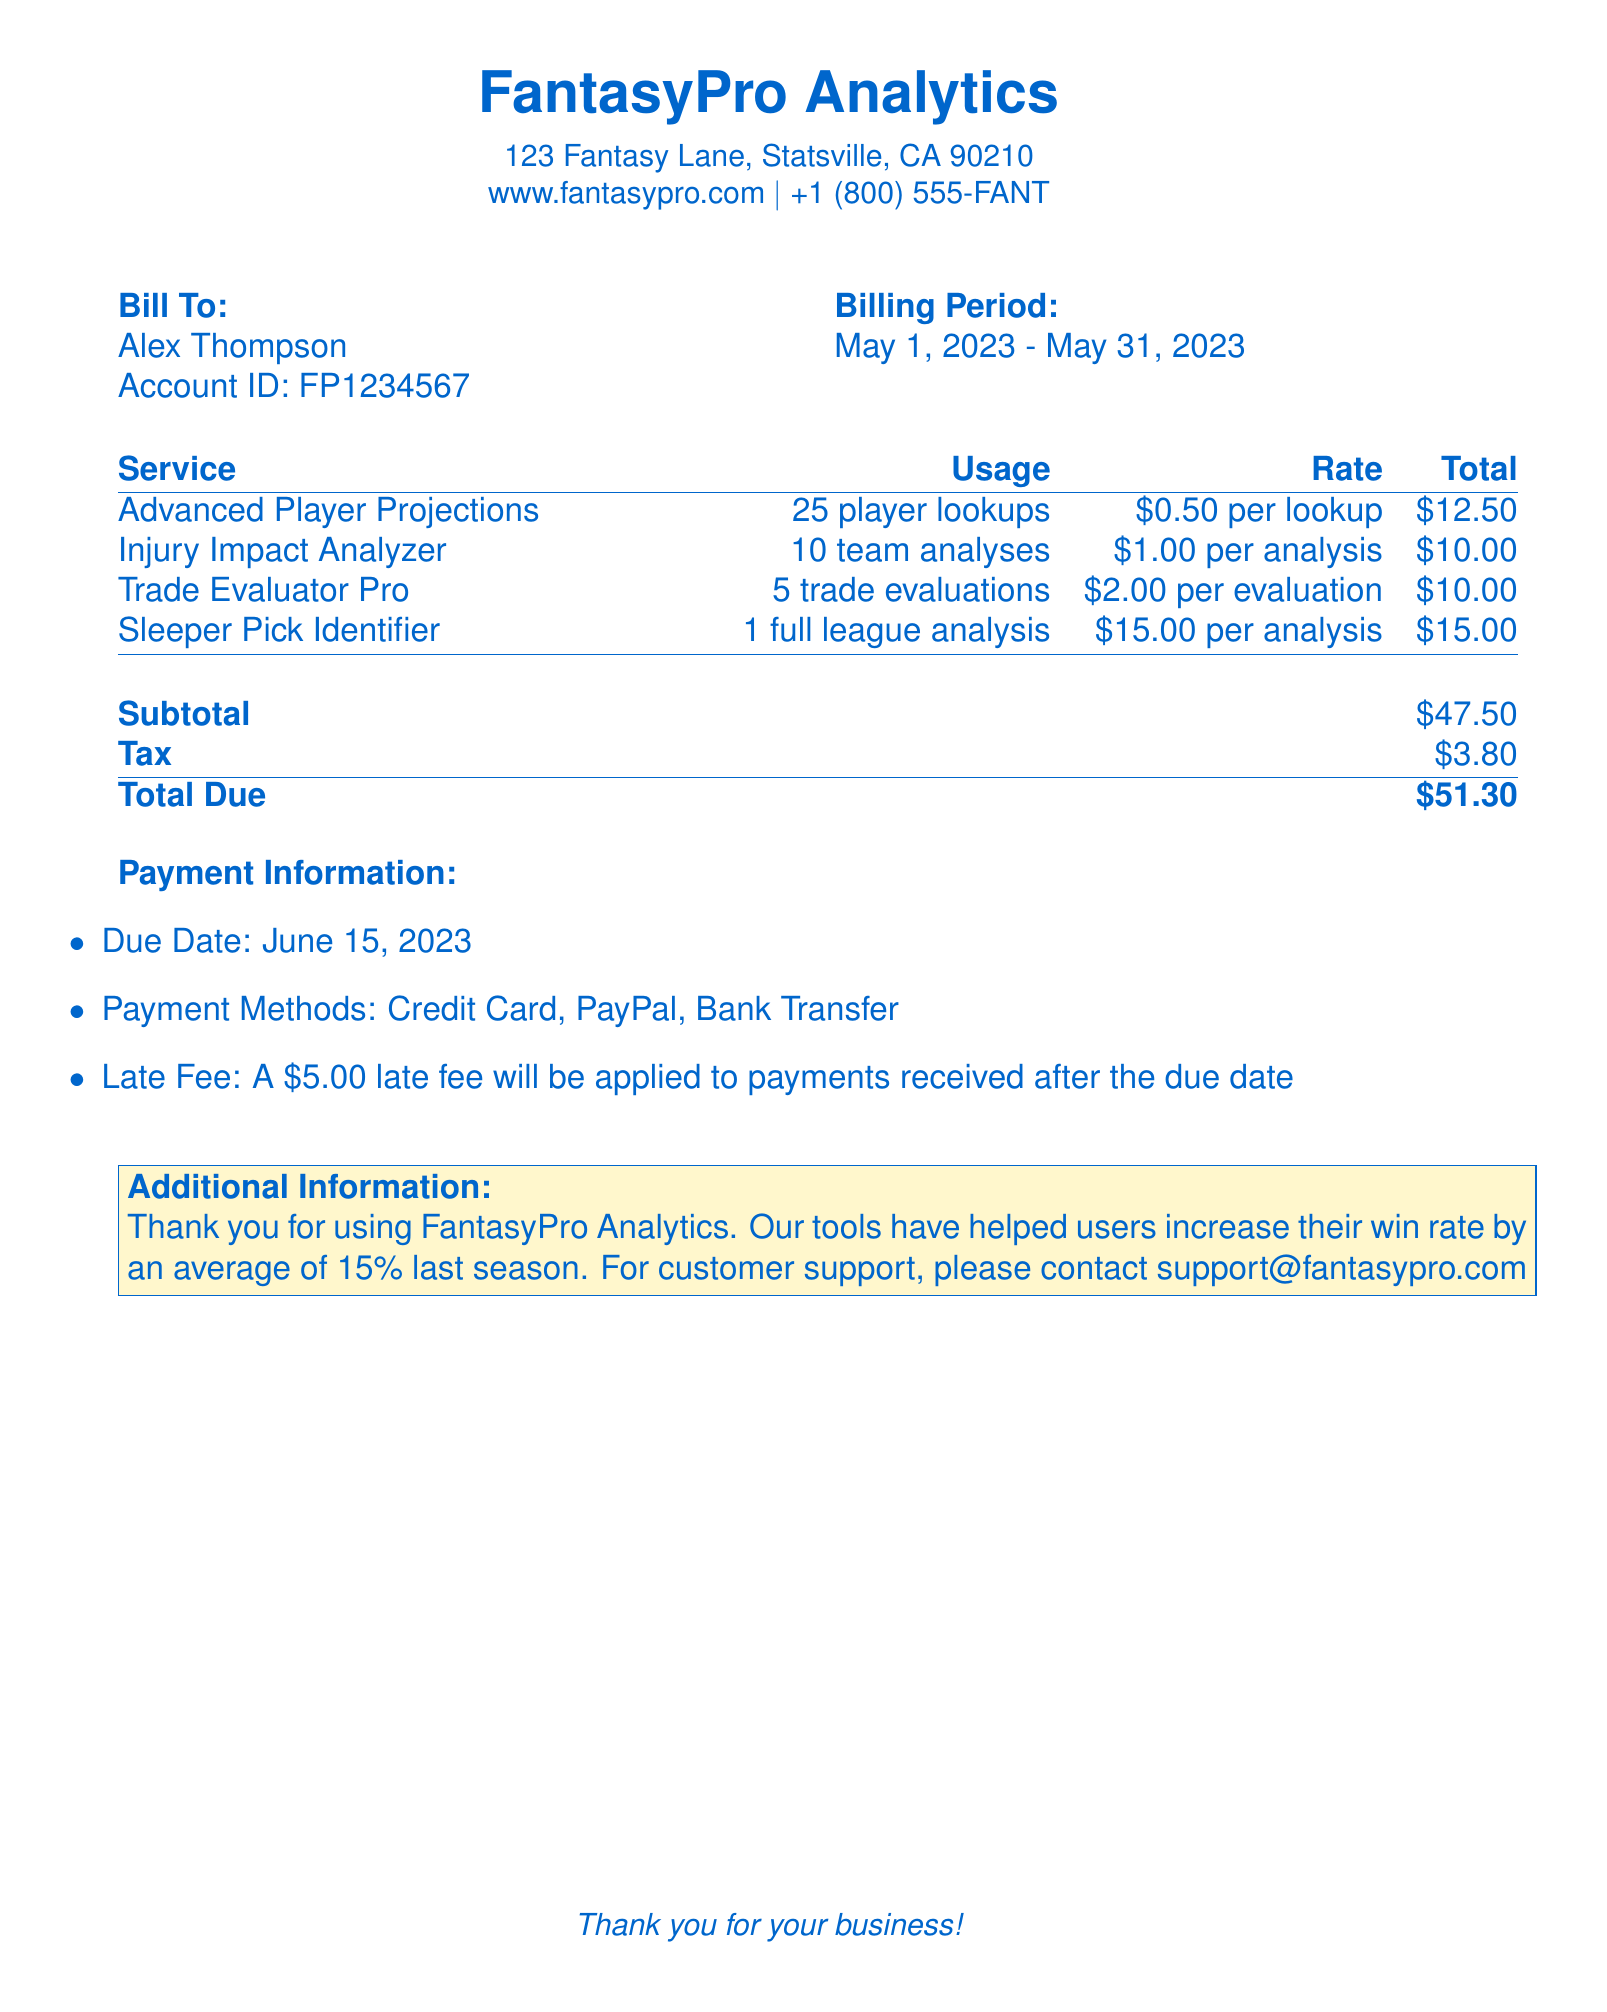What is the total due amount? The total due amount is stated at the bottom of the document, summing the subtotal and tax.
Answer: $51.30 What is the billing period? The billing period is indicated near the top of the document, specifying the time frame for the services billed.
Answer: May 1, 2023 - May 31, 2023 How many player lookups were performed? The number of player lookups is detailed under the services section of the bill.
Answer: 25 player lookups What is the rate for a team analysis? The rate for a team analysis can be found next to the Injury Impact Analyzer service in the bill.
Answer: $1.00 per analysis What is the late fee amount? The late fee is explicitly mentioned in the payment information section of the bill.
Answer: $5.00 What is the total usage cost for the Advanced Player Projections? The total usage cost for this service is calculated based on the number of lookups and the rate specified.
Answer: $12.50 How many trade evaluations were conducted? The document provides a count of trade evaluations under the service section.
Answer: 5 trade evaluations What payment methods are accepted? The accepted payment methods are listed in the payment information section of the bill.
Answer: Credit Card, PayPal, Bank Transfer What additional information is provided at the end of the document? The additional information provides insights into the effectiveness of FantasyPro Analytics tools for users.
Answer: Thank you for using FantasyPro Analytics.. 